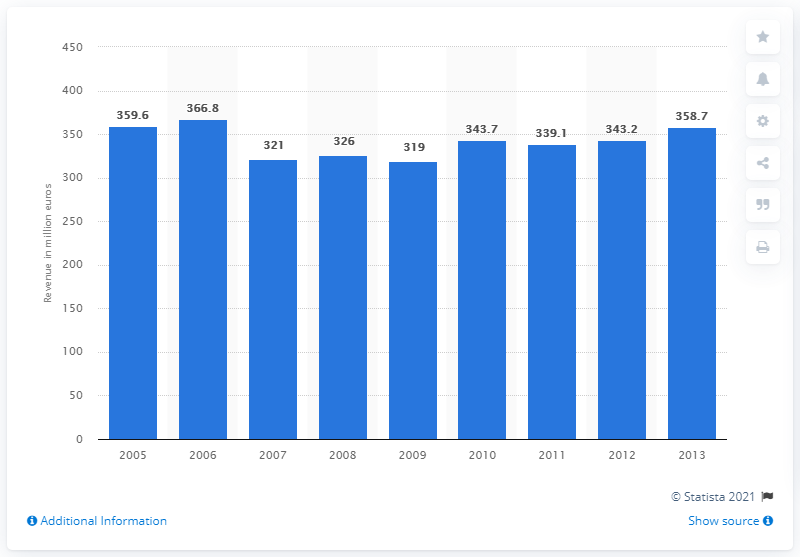What was the revenue of Head N.V. in 2006?
 366.8 